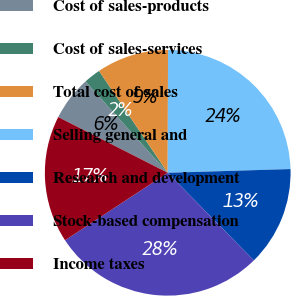Convert chart. <chart><loc_0><loc_0><loc_500><loc_500><pie_chart><fcel>Cost of sales-products<fcel>Cost of sales-services<fcel>Total cost of sales<fcel>Selling general and<fcel>Research and development<fcel>Stock-based compensation<fcel>Income taxes<nl><fcel>5.85%<fcel>2.22%<fcel>9.48%<fcel>24.48%<fcel>13.12%<fcel>28.11%<fcel>16.75%<nl></chart> 